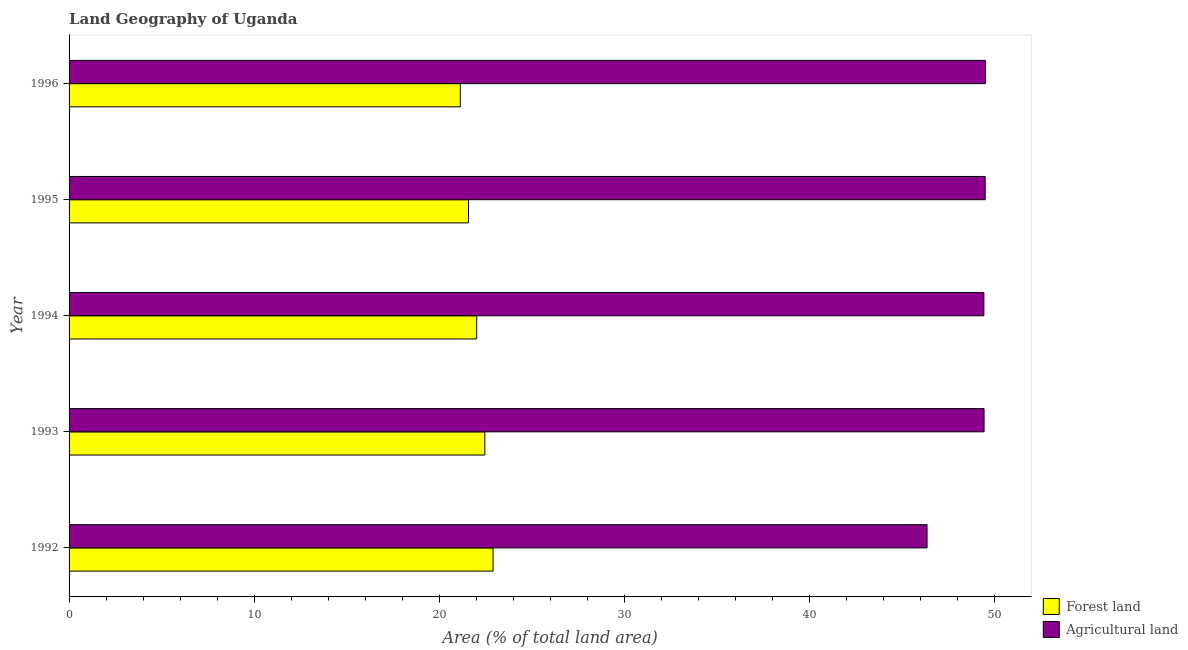How many different coloured bars are there?
Provide a short and direct response. 2. How many groups of bars are there?
Offer a terse response. 5. Are the number of bars per tick equal to the number of legend labels?
Give a very brief answer. Yes. Are the number of bars on each tick of the Y-axis equal?
Your response must be concise. Yes. How many bars are there on the 3rd tick from the bottom?
Your answer should be very brief. 2. What is the percentage of land area under agriculture in 1993?
Offer a terse response. 49.41. Across all years, what is the maximum percentage of land area under forests?
Your answer should be very brief. 22.89. Across all years, what is the minimum percentage of land area under agriculture?
Keep it short and to the point. 46.33. In which year was the percentage of land area under agriculture maximum?
Ensure brevity in your answer.  1996. In which year was the percentage of land area under forests minimum?
Make the answer very short. 1996. What is the total percentage of land area under forests in the graph?
Your answer should be very brief. 110.06. What is the difference between the percentage of land area under forests in 1992 and that in 1993?
Keep it short and to the point. 0.44. What is the difference between the percentage of land area under agriculture in 1992 and the percentage of land area under forests in 1996?
Keep it short and to the point. 25.2. What is the average percentage of land area under agriculture per year?
Provide a short and direct response. 48.82. In the year 1993, what is the difference between the percentage of land area under agriculture and percentage of land area under forests?
Provide a succinct answer. 26.96. What is the ratio of the percentage of land area under forests in 1992 to that in 1996?
Give a very brief answer. 1.08. Is the difference between the percentage of land area under agriculture in 1992 and 1995 greater than the difference between the percentage of land area under forests in 1992 and 1995?
Give a very brief answer. No. What is the difference between the highest and the second highest percentage of land area under agriculture?
Make the answer very short. 0.01. What is the difference between the highest and the lowest percentage of land area under forests?
Your answer should be very brief. 1.77. In how many years, is the percentage of land area under agriculture greater than the average percentage of land area under agriculture taken over all years?
Give a very brief answer. 4. What does the 1st bar from the top in 1996 represents?
Ensure brevity in your answer.  Agricultural land. What does the 1st bar from the bottom in 1993 represents?
Your answer should be very brief. Forest land. Are all the bars in the graph horizontal?
Offer a terse response. Yes. What is the difference between two consecutive major ticks on the X-axis?
Your response must be concise. 10. Are the values on the major ticks of X-axis written in scientific E-notation?
Offer a terse response. No. Where does the legend appear in the graph?
Ensure brevity in your answer.  Bottom right. How many legend labels are there?
Your answer should be very brief. 2. How are the legend labels stacked?
Offer a very short reply. Vertical. What is the title of the graph?
Give a very brief answer. Land Geography of Uganda. Does "Working capital" appear as one of the legend labels in the graph?
Give a very brief answer. No. What is the label or title of the X-axis?
Offer a very short reply. Area (% of total land area). What is the Area (% of total land area) of Forest land in 1992?
Make the answer very short. 22.89. What is the Area (% of total land area) in Agricultural land in 1992?
Keep it short and to the point. 46.33. What is the Area (% of total land area) of Forest land in 1993?
Offer a terse response. 22.45. What is the Area (% of total land area) of Agricultural land in 1993?
Keep it short and to the point. 49.41. What is the Area (% of total land area) in Forest land in 1994?
Make the answer very short. 22.01. What is the Area (% of total land area) in Agricultural land in 1994?
Offer a terse response. 49.4. What is the Area (% of total land area) in Forest land in 1995?
Make the answer very short. 21.57. What is the Area (% of total land area) of Agricultural land in 1995?
Offer a very short reply. 49.47. What is the Area (% of total land area) in Forest land in 1996?
Make the answer very short. 21.13. What is the Area (% of total land area) of Agricultural land in 1996?
Offer a very short reply. 49.49. Across all years, what is the maximum Area (% of total land area) of Forest land?
Provide a succinct answer. 22.89. Across all years, what is the maximum Area (% of total land area) of Agricultural land?
Your response must be concise. 49.49. Across all years, what is the minimum Area (% of total land area) of Forest land?
Your response must be concise. 21.13. Across all years, what is the minimum Area (% of total land area) of Agricultural land?
Ensure brevity in your answer.  46.33. What is the total Area (% of total land area) in Forest land in the graph?
Keep it short and to the point. 110.06. What is the total Area (% of total land area) of Agricultural land in the graph?
Keep it short and to the point. 244.11. What is the difference between the Area (% of total land area) in Forest land in 1992 and that in 1993?
Give a very brief answer. 0.44. What is the difference between the Area (% of total land area) of Agricultural land in 1992 and that in 1993?
Keep it short and to the point. -3.08. What is the difference between the Area (% of total land area) in Forest land in 1992 and that in 1994?
Offer a very short reply. 0.88. What is the difference between the Area (% of total land area) in Agricultural land in 1992 and that in 1994?
Your response must be concise. -3.07. What is the difference between the Area (% of total land area) in Forest land in 1992 and that in 1995?
Keep it short and to the point. 1.32. What is the difference between the Area (% of total land area) in Agricultural land in 1992 and that in 1995?
Your answer should be very brief. -3.14. What is the difference between the Area (% of total land area) in Forest land in 1992 and that in 1996?
Offer a terse response. 1.77. What is the difference between the Area (% of total land area) of Agricultural land in 1992 and that in 1996?
Give a very brief answer. -3.15. What is the difference between the Area (% of total land area) in Forest land in 1993 and that in 1994?
Your response must be concise. 0.44. What is the difference between the Area (% of total land area) in Agricultural land in 1993 and that in 1994?
Make the answer very short. 0.01. What is the difference between the Area (% of total land area) of Forest land in 1993 and that in 1995?
Give a very brief answer. 0.88. What is the difference between the Area (% of total land area) of Agricultural land in 1993 and that in 1995?
Give a very brief answer. -0.06. What is the difference between the Area (% of total land area) in Forest land in 1993 and that in 1996?
Your answer should be compact. 1.32. What is the difference between the Area (% of total land area) of Agricultural land in 1993 and that in 1996?
Offer a very short reply. -0.08. What is the difference between the Area (% of total land area) of Forest land in 1994 and that in 1995?
Your answer should be compact. 0.44. What is the difference between the Area (% of total land area) of Agricultural land in 1994 and that in 1995?
Ensure brevity in your answer.  -0.07. What is the difference between the Area (% of total land area) of Forest land in 1994 and that in 1996?
Your response must be concise. 0.88. What is the difference between the Area (% of total land area) of Agricultural land in 1994 and that in 1996?
Ensure brevity in your answer.  -0.09. What is the difference between the Area (% of total land area) in Forest land in 1995 and that in 1996?
Your answer should be very brief. 0.44. What is the difference between the Area (% of total land area) in Agricultural land in 1995 and that in 1996?
Keep it short and to the point. -0.01. What is the difference between the Area (% of total land area) in Forest land in 1992 and the Area (% of total land area) in Agricultural land in 1993?
Ensure brevity in your answer.  -26.52. What is the difference between the Area (% of total land area) of Forest land in 1992 and the Area (% of total land area) of Agricultural land in 1994?
Your response must be concise. -26.51. What is the difference between the Area (% of total land area) of Forest land in 1992 and the Area (% of total land area) of Agricultural land in 1995?
Give a very brief answer. -26.58. What is the difference between the Area (% of total land area) in Forest land in 1992 and the Area (% of total land area) in Agricultural land in 1996?
Provide a short and direct response. -26.59. What is the difference between the Area (% of total land area) in Forest land in 1993 and the Area (% of total land area) in Agricultural land in 1994?
Your response must be concise. -26.95. What is the difference between the Area (% of total land area) of Forest land in 1993 and the Area (% of total land area) of Agricultural land in 1995?
Offer a very short reply. -27.02. What is the difference between the Area (% of total land area) in Forest land in 1993 and the Area (% of total land area) in Agricultural land in 1996?
Offer a terse response. -27.03. What is the difference between the Area (% of total land area) of Forest land in 1994 and the Area (% of total land area) of Agricultural land in 1995?
Provide a short and direct response. -27.46. What is the difference between the Area (% of total land area) in Forest land in 1994 and the Area (% of total land area) in Agricultural land in 1996?
Offer a very short reply. -27.48. What is the difference between the Area (% of total land area) in Forest land in 1995 and the Area (% of total land area) in Agricultural land in 1996?
Ensure brevity in your answer.  -27.92. What is the average Area (% of total land area) in Forest land per year?
Make the answer very short. 22.01. What is the average Area (% of total land area) in Agricultural land per year?
Your answer should be compact. 48.82. In the year 1992, what is the difference between the Area (% of total land area) in Forest land and Area (% of total land area) in Agricultural land?
Provide a succinct answer. -23.44. In the year 1993, what is the difference between the Area (% of total land area) of Forest land and Area (% of total land area) of Agricultural land?
Keep it short and to the point. -26.96. In the year 1994, what is the difference between the Area (% of total land area) in Forest land and Area (% of total land area) in Agricultural land?
Ensure brevity in your answer.  -27.39. In the year 1995, what is the difference between the Area (% of total land area) of Forest land and Area (% of total land area) of Agricultural land?
Keep it short and to the point. -27.9. In the year 1996, what is the difference between the Area (% of total land area) of Forest land and Area (% of total land area) of Agricultural land?
Ensure brevity in your answer.  -28.36. What is the ratio of the Area (% of total land area) of Forest land in 1992 to that in 1993?
Offer a terse response. 1.02. What is the ratio of the Area (% of total land area) in Agricultural land in 1992 to that in 1993?
Provide a short and direct response. 0.94. What is the ratio of the Area (% of total land area) in Forest land in 1992 to that in 1994?
Your answer should be compact. 1.04. What is the ratio of the Area (% of total land area) in Agricultural land in 1992 to that in 1994?
Offer a terse response. 0.94. What is the ratio of the Area (% of total land area) in Forest land in 1992 to that in 1995?
Provide a short and direct response. 1.06. What is the ratio of the Area (% of total land area) in Agricultural land in 1992 to that in 1995?
Keep it short and to the point. 0.94. What is the ratio of the Area (% of total land area) of Forest land in 1992 to that in 1996?
Give a very brief answer. 1.08. What is the ratio of the Area (% of total land area) in Agricultural land in 1992 to that in 1996?
Ensure brevity in your answer.  0.94. What is the ratio of the Area (% of total land area) of Forest land in 1993 to that in 1994?
Ensure brevity in your answer.  1.02. What is the ratio of the Area (% of total land area) in Agricultural land in 1993 to that in 1994?
Give a very brief answer. 1. What is the ratio of the Area (% of total land area) of Forest land in 1993 to that in 1995?
Keep it short and to the point. 1.04. What is the ratio of the Area (% of total land area) of Forest land in 1993 to that in 1996?
Give a very brief answer. 1.06. What is the ratio of the Area (% of total land area) in Forest land in 1994 to that in 1995?
Provide a short and direct response. 1.02. What is the ratio of the Area (% of total land area) of Agricultural land in 1994 to that in 1995?
Provide a succinct answer. 1. What is the ratio of the Area (% of total land area) of Forest land in 1994 to that in 1996?
Keep it short and to the point. 1.04. What is the ratio of the Area (% of total land area) of Agricultural land in 1994 to that in 1996?
Your answer should be very brief. 1. What is the ratio of the Area (% of total land area) of Forest land in 1995 to that in 1996?
Keep it short and to the point. 1.02. What is the ratio of the Area (% of total land area) in Agricultural land in 1995 to that in 1996?
Your response must be concise. 1. What is the difference between the highest and the second highest Area (% of total land area) in Forest land?
Give a very brief answer. 0.44. What is the difference between the highest and the second highest Area (% of total land area) in Agricultural land?
Provide a succinct answer. 0.01. What is the difference between the highest and the lowest Area (% of total land area) in Forest land?
Ensure brevity in your answer.  1.77. What is the difference between the highest and the lowest Area (% of total land area) in Agricultural land?
Keep it short and to the point. 3.15. 